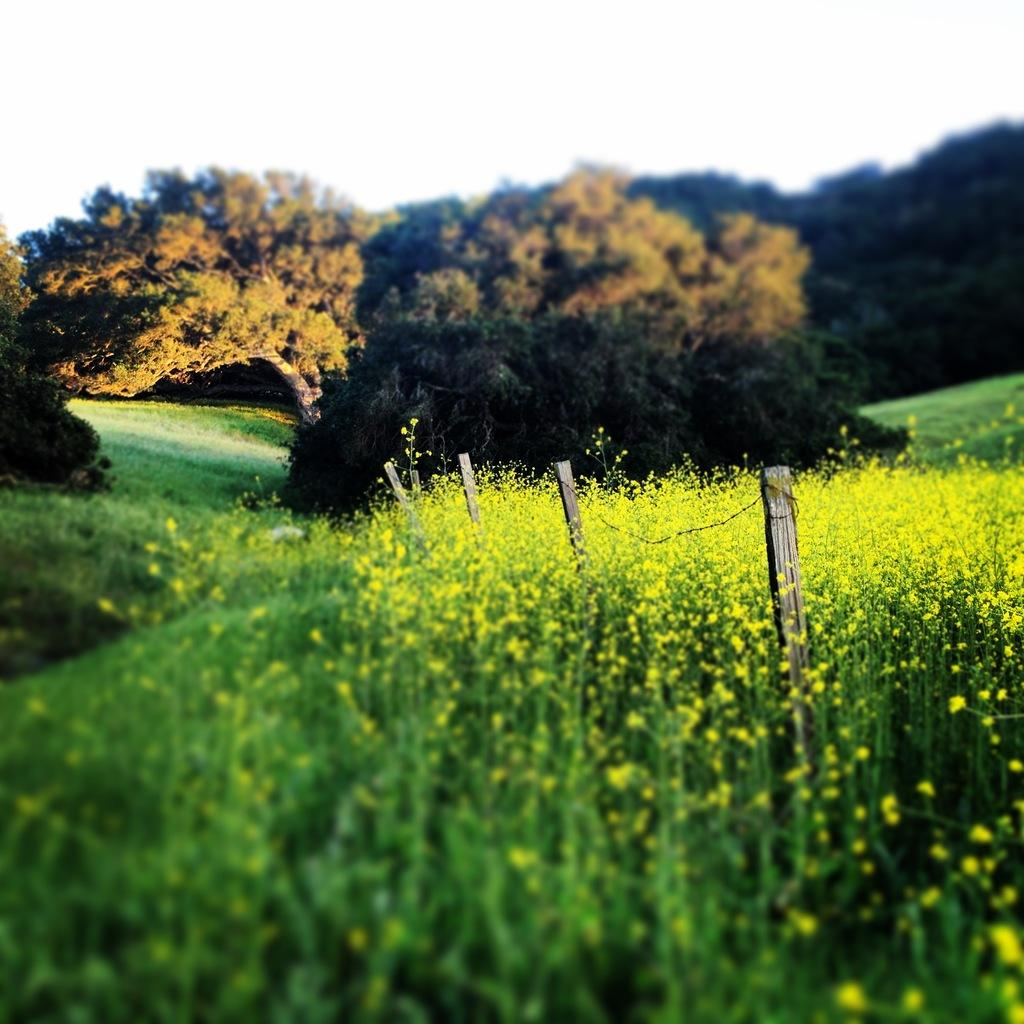What type of vegetation can be seen in the image? There are trees in the image. What is present at the bottom of the image? There is grass at the bottom of the image. What structure is visible in the image? There is a fence in the image. What can be seen in the background of the image? The sky is visible in the background of the image. How many cherries are hanging from the trees in the image? There is no mention of cherries in the image; it only features trees. Can you see any cats playing in the grass in the image? There are no cats present in the image; it only features trees, grass, a fence, and the sky. 